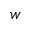<formula> <loc_0><loc_0><loc_500><loc_500>w</formula> 